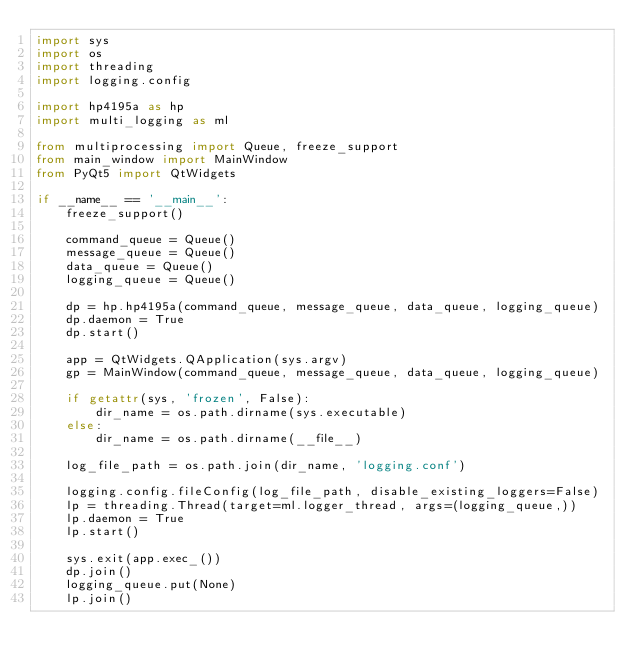<code> <loc_0><loc_0><loc_500><loc_500><_Python_>import sys
import os
import threading
import logging.config

import hp4195a as hp
import multi_logging as ml

from multiprocessing import Queue, freeze_support
from main_window import MainWindow
from PyQt5 import QtWidgets

if __name__ == '__main__':
    freeze_support()

    command_queue = Queue()
    message_queue = Queue()
    data_queue = Queue()
    logging_queue = Queue()

    dp = hp.hp4195a(command_queue, message_queue, data_queue, logging_queue)
    dp.daemon = True
    dp.start()

    app = QtWidgets.QApplication(sys.argv)
    gp = MainWindow(command_queue, message_queue, data_queue, logging_queue)

    if getattr(sys, 'frozen', False):
        dir_name = os.path.dirname(sys.executable)
    else:
        dir_name = os.path.dirname(__file__)

    log_file_path = os.path.join(dir_name, 'logging.conf')

    logging.config.fileConfig(log_file_path, disable_existing_loggers=False)
    lp = threading.Thread(target=ml.logger_thread, args=(logging_queue,))
    lp.daemon = True
    lp.start()

    sys.exit(app.exec_())
    dp.join()
    logging_queue.put(None)
    lp.join()
</code> 